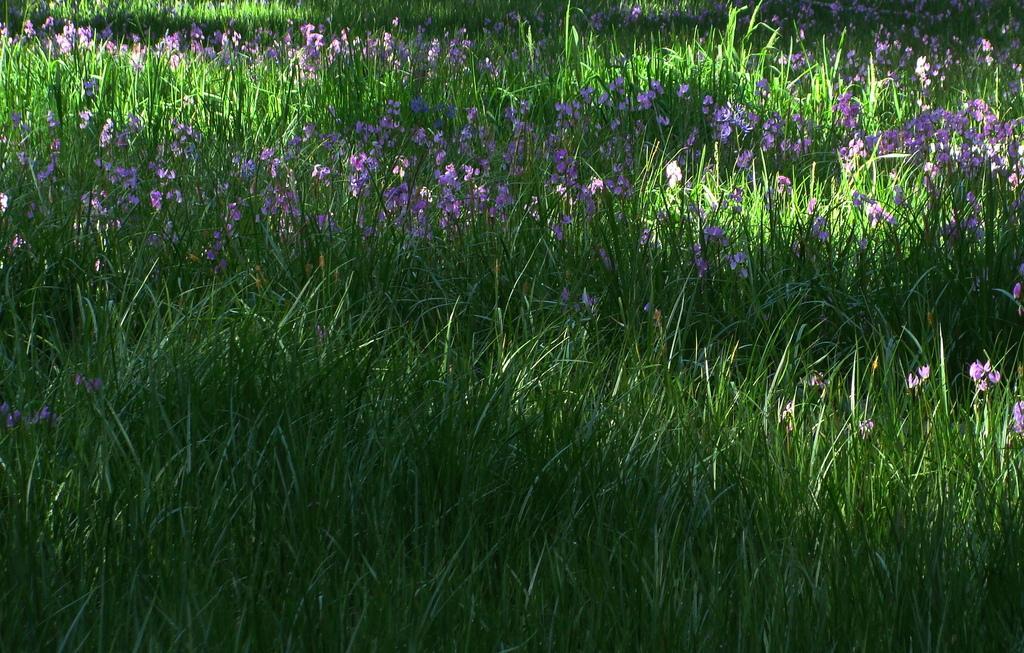How would you summarize this image in a sentence or two? In this picture I can see grass and flowers. 